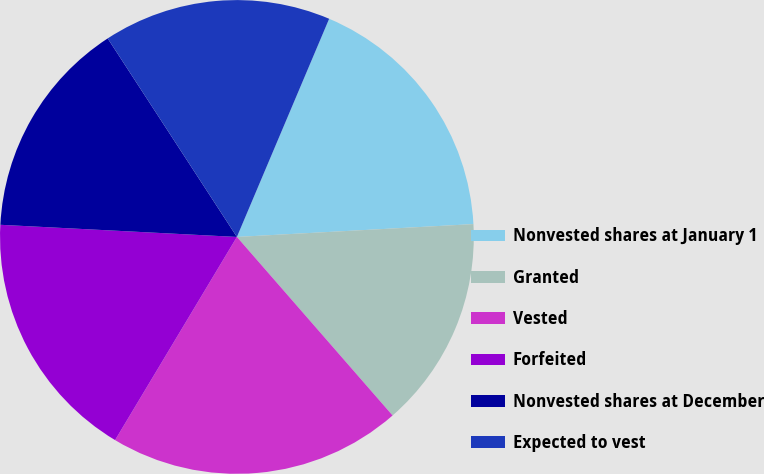Convert chart to OTSL. <chart><loc_0><loc_0><loc_500><loc_500><pie_chart><fcel>Nonvested shares at January 1<fcel>Granted<fcel>Vested<fcel>Forfeited<fcel>Nonvested shares at December<fcel>Expected to vest<nl><fcel>17.77%<fcel>14.45%<fcel>20.01%<fcel>17.22%<fcel>15.0%<fcel>15.55%<nl></chart> 